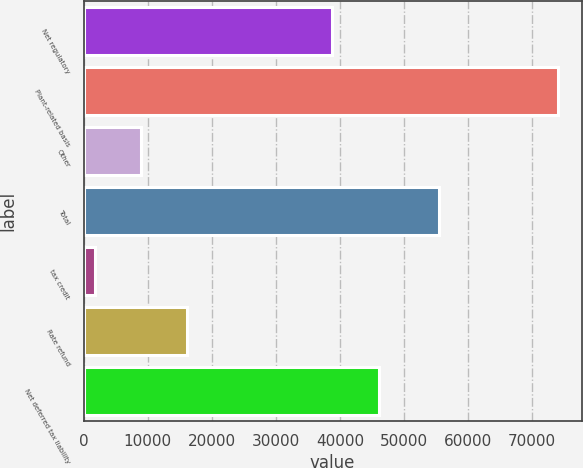Convert chart. <chart><loc_0><loc_0><loc_500><loc_500><bar_chart><fcel>Net regulatory<fcel>Plant-related basis<fcel>Other<fcel>Total<fcel>tax credit<fcel>Rate refund<fcel>Net deferred tax liability<nl><fcel>38834<fcel>74041<fcel>8942.2<fcel>55535<fcel>1709<fcel>16175.4<fcel>46067.2<nl></chart> 